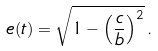<formula> <loc_0><loc_0><loc_500><loc_500>e ( t ) = \sqrt { 1 - \left ( \frac { c } { b } \right ) ^ { 2 } } \, .</formula> 